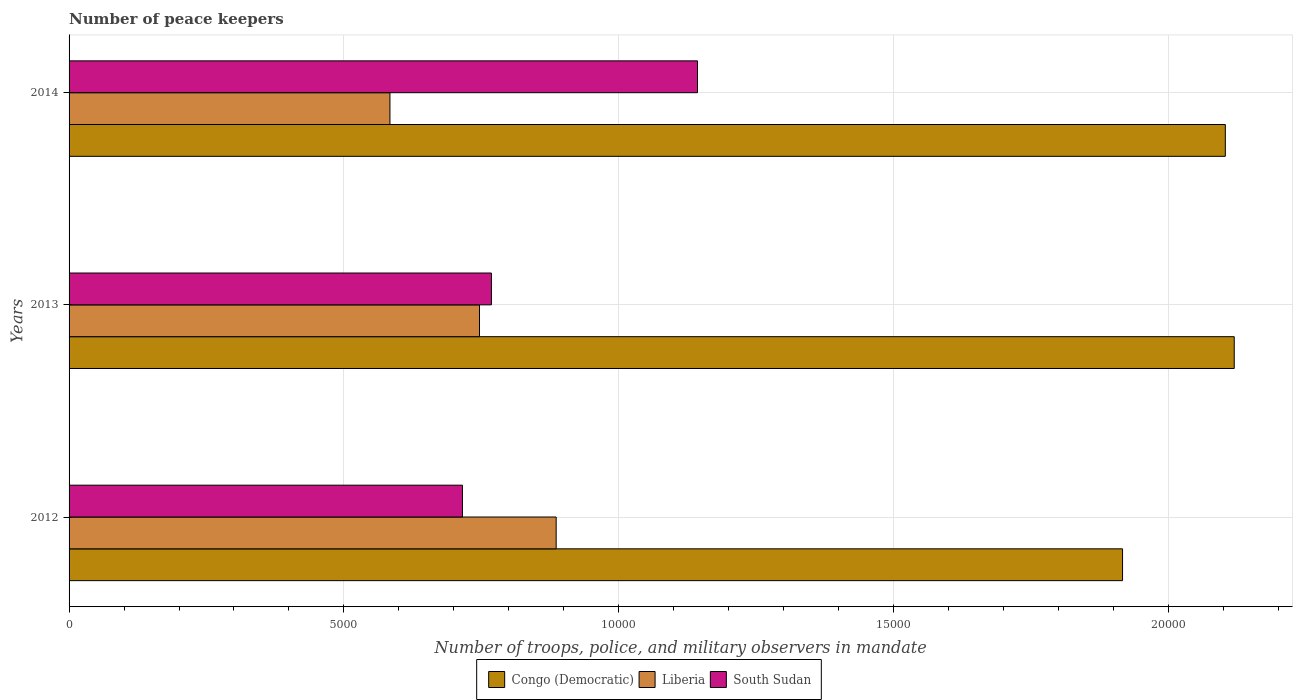How many different coloured bars are there?
Keep it short and to the point. 3. Are the number of bars on each tick of the Y-axis equal?
Offer a very short reply. Yes. How many bars are there on the 3rd tick from the bottom?
Give a very brief answer. 3. In how many cases, is the number of bars for a given year not equal to the number of legend labels?
Offer a terse response. 0. What is the number of peace keepers in in Liberia in 2013?
Give a very brief answer. 7467. Across all years, what is the maximum number of peace keepers in in South Sudan?
Make the answer very short. 1.14e+04. Across all years, what is the minimum number of peace keepers in in Liberia?
Offer a very short reply. 5838. In which year was the number of peace keepers in in Congo (Democratic) maximum?
Offer a very short reply. 2013. In which year was the number of peace keepers in in Liberia minimum?
Your answer should be very brief. 2014. What is the total number of peace keepers in in Liberia in the graph?
Keep it short and to the point. 2.22e+04. What is the difference between the number of peace keepers in in Congo (Democratic) in 2012 and that in 2014?
Your response must be concise. -1870. What is the difference between the number of peace keepers in in South Sudan in 2013 and the number of peace keepers in in Congo (Democratic) in 2012?
Give a very brief answer. -1.15e+04. What is the average number of peace keepers in in Liberia per year?
Your response must be concise. 7389. In the year 2012, what is the difference between the number of peace keepers in in Liberia and number of peace keepers in in South Sudan?
Offer a very short reply. 1705. In how many years, is the number of peace keepers in in Liberia greater than 2000 ?
Your answer should be very brief. 3. What is the ratio of the number of peace keepers in in Liberia in 2012 to that in 2013?
Offer a terse response. 1.19. Is the number of peace keepers in in Congo (Democratic) in 2013 less than that in 2014?
Offer a very short reply. No. What is the difference between the highest and the second highest number of peace keepers in in Liberia?
Give a very brief answer. 1395. What is the difference between the highest and the lowest number of peace keepers in in Liberia?
Your answer should be very brief. 3024. What does the 1st bar from the top in 2012 represents?
Provide a succinct answer. South Sudan. What does the 2nd bar from the bottom in 2012 represents?
Provide a succinct answer. Liberia. Is it the case that in every year, the sum of the number of peace keepers in in Liberia and number of peace keepers in in South Sudan is greater than the number of peace keepers in in Congo (Democratic)?
Make the answer very short. No. Are all the bars in the graph horizontal?
Provide a succinct answer. Yes. How many years are there in the graph?
Give a very brief answer. 3. What is the difference between two consecutive major ticks on the X-axis?
Give a very brief answer. 5000. Are the values on the major ticks of X-axis written in scientific E-notation?
Give a very brief answer. No. Does the graph contain grids?
Make the answer very short. Yes. How many legend labels are there?
Give a very brief answer. 3. What is the title of the graph?
Keep it short and to the point. Number of peace keepers. Does "World" appear as one of the legend labels in the graph?
Provide a short and direct response. No. What is the label or title of the X-axis?
Make the answer very short. Number of troops, police, and military observers in mandate. What is the label or title of the Y-axis?
Ensure brevity in your answer.  Years. What is the Number of troops, police, and military observers in mandate of Congo (Democratic) in 2012?
Offer a terse response. 1.92e+04. What is the Number of troops, police, and military observers in mandate in Liberia in 2012?
Give a very brief answer. 8862. What is the Number of troops, police, and military observers in mandate in South Sudan in 2012?
Keep it short and to the point. 7157. What is the Number of troops, police, and military observers in mandate in Congo (Democratic) in 2013?
Provide a succinct answer. 2.12e+04. What is the Number of troops, police, and military observers in mandate of Liberia in 2013?
Your answer should be very brief. 7467. What is the Number of troops, police, and military observers in mandate of South Sudan in 2013?
Offer a terse response. 7684. What is the Number of troops, police, and military observers in mandate of Congo (Democratic) in 2014?
Provide a succinct answer. 2.10e+04. What is the Number of troops, police, and military observers in mandate in Liberia in 2014?
Your answer should be compact. 5838. What is the Number of troops, police, and military observers in mandate of South Sudan in 2014?
Make the answer very short. 1.14e+04. Across all years, what is the maximum Number of troops, police, and military observers in mandate of Congo (Democratic)?
Provide a succinct answer. 2.12e+04. Across all years, what is the maximum Number of troops, police, and military observers in mandate of Liberia?
Ensure brevity in your answer.  8862. Across all years, what is the maximum Number of troops, police, and military observers in mandate of South Sudan?
Give a very brief answer. 1.14e+04. Across all years, what is the minimum Number of troops, police, and military observers in mandate in Congo (Democratic)?
Your answer should be compact. 1.92e+04. Across all years, what is the minimum Number of troops, police, and military observers in mandate in Liberia?
Your response must be concise. 5838. Across all years, what is the minimum Number of troops, police, and military observers in mandate in South Sudan?
Your response must be concise. 7157. What is the total Number of troops, police, and military observers in mandate of Congo (Democratic) in the graph?
Your answer should be compact. 6.14e+04. What is the total Number of troops, police, and military observers in mandate of Liberia in the graph?
Give a very brief answer. 2.22e+04. What is the total Number of troops, police, and military observers in mandate in South Sudan in the graph?
Keep it short and to the point. 2.63e+04. What is the difference between the Number of troops, police, and military observers in mandate of Congo (Democratic) in 2012 and that in 2013?
Make the answer very short. -2032. What is the difference between the Number of troops, police, and military observers in mandate of Liberia in 2012 and that in 2013?
Offer a very short reply. 1395. What is the difference between the Number of troops, police, and military observers in mandate in South Sudan in 2012 and that in 2013?
Offer a terse response. -527. What is the difference between the Number of troops, police, and military observers in mandate in Congo (Democratic) in 2012 and that in 2014?
Keep it short and to the point. -1870. What is the difference between the Number of troops, police, and military observers in mandate of Liberia in 2012 and that in 2014?
Make the answer very short. 3024. What is the difference between the Number of troops, police, and military observers in mandate of South Sudan in 2012 and that in 2014?
Give a very brief answer. -4276. What is the difference between the Number of troops, police, and military observers in mandate in Congo (Democratic) in 2013 and that in 2014?
Keep it short and to the point. 162. What is the difference between the Number of troops, police, and military observers in mandate in Liberia in 2013 and that in 2014?
Keep it short and to the point. 1629. What is the difference between the Number of troops, police, and military observers in mandate of South Sudan in 2013 and that in 2014?
Your answer should be compact. -3749. What is the difference between the Number of troops, police, and military observers in mandate in Congo (Democratic) in 2012 and the Number of troops, police, and military observers in mandate in Liberia in 2013?
Offer a terse response. 1.17e+04. What is the difference between the Number of troops, police, and military observers in mandate of Congo (Democratic) in 2012 and the Number of troops, police, and military observers in mandate of South Sudan in 2013?
Make the answer very short. 1.15e+04. What is the difference between the Number of troops, police, and military observers in mandate of Liberia in 2012 and the Number of troops, police, and military observers in mandate of South Sudan in 2013?
Provide a succinct answer. 1178. What is the difference between the Number of troops, police, and military observers in mandate of Congo (Democratic) in 2012 and the Number of troops, police, and military observers in mandate of Liberia in 2014?
Offer a very short reply. 1.33e+04. What is the difference between the Number of troops, police, and military observers in mandate in Congo (Democratic) in 2012 and the Number of troops, police, and military observers in mandate in South Sudan in 2014?
Give a very brief answer. 7733. What is the difference between the Number of troops, police, and military observers in mandate of Liberia in 2012 and the Number of troops, police, and military observers in mandate of South Sudan in 2014?
Ensure brevity in your answer.  -2571. What is the difference between the Number of troops, police, and military observers in mandate of Congo (Democratic) in 2013 and the Number of troops, police, and military observers in mandate of Liberia in 2014?
Provide a short and direct response. 1.54e+04. What is the difference between the Number of troops, police, and military observers in mandate of Congo (Democratic) in 2013 and the Number of troops, police, and military observers in mandate of South Sudan in 2014?
Give a very brief answer. 9765. What is the difference between the Number of troops, police, and military observers in mandate of Liberia in 2013 and the Number of troops, police, and military observers in mandate of South Sudan in 2014?
Give a very brief answer. -3966. What is the average Number of troops, police, and military observers in mandate in Congo (Democratic) per year?
Ensure brevity in your answer.  2.05e+04. What is the average Number of troops, police, and military observers in mandate of Liberia per year?
Offer a terse response. 7389. What is the average Number of troops, police, and military observers in mandate of South Sudan per year?
Make the answer very short. 8758. In the year 2012, what is the difference between the Number of troops, police, and military observers in mandate of Congo (Democratic) and Number of troops, police, and military observers in mandate of Liberia?
Your response must be concise. 1.03e+04. In the year 2012, what is the difference between the Number of troops, police, and military observers in mandate in Congo (Democratic) and Number of troops, police, and military observers in mandate in South Sudan?
Give a very brief answer. 1.20e+04. In the year 2012, what is the difference between the Number of troops, police, and military observers in mandate in Liberia and Number of troops, police, and military observers in mandate in South Sudan?
Your answer should be compact. 1705. In the year 2013, what is the difference between the Number of troops, police, and military observers in mandate of Congo (Democratic) and Number of troops, police, and military observers in mandate of Liberia?
Keep it short and to the point. 1.37e+04. In the year 2013, what is the difference between the Number of troops, police, and military observers in mandate of Congo (Democratic) and Number of troops, police, and military observers in mandate of South Sudan?
Provide a short and direct response. 1.35e+04. In the year 2013, what is the difference between the Number of troops, police, and military observers in mandate of Liberia and Number of troops, police, and military observers in mandate of South Sudan?
Your response must be concise. -217. In the year 2014, what is the difference between the Number of troops, police, and military observers in mandate in Congo (Democratic) and Number of troops, police, and military observers in mandate in Liberia?
Provide a short and direct response. 1.52e+04. In the year 2014, what is the difference between the Number of troops, police, and military observers in mandate in Congo (Democratic) and Number of troops, police, and military observers in mandate in South Sudan?
Provide a short and direct response. 9603. In the year 2014, what is the difference between the Number of troops, police, and military observers in mandate of Liberia and Number of troops, police, and military observers in mandate of South Sudan?
Keep it short and to the point. -5595. What is the ratio of the Number of troops, police, and military observers in mandate of Congo (Democratic) in 2012 to that in 2013?
Ensure brevity in your answer.  0.9. What is the ratio of the Number of troops, police, and military observers in mandate in Liberia in 2012 to that in 2013?
Provide a short and direct response. 1.19. What is the ratio of the Number of troops, police, and military observers in mandate in South Sudan in 2012 to that in 2013?
Offer a very short reply. 0.93. What is the ratio of the Number of troops, police, and military observers in mandate of Congo (Democratic) in 2012 to that in 2014?
Provide a short and direct response. 0.91. What is the ratio of the Number of troops, police, and military observers in mandate in Liberia in 2012 to that in 2014?
Ensure brevity in your answer.  1.52. What is the ratio of the Number of troops, police, and military observers in mandate in South Sudan in 2012 to that in 2014?
Ensure brevity in your answer.  0.63. What is the ratio of the Number of troops, police, and military observers in mandate in Congo (Democratic) in 2013 to that in 2014?
Give a very brief answer. 1.01. What is the ratio of the Number of troops, police, and military observers in mandate of Liberia in 2013 to that in 2014?
Keep it short and to the point. 1.28. What is the ratio of the Number of troops, police, and military observers in mandate in South Sudan in 2013 to that in 2014?
Keep it short and to the point. 0.67. What is the difference between the highest and the second highest Number of troops, police, and military observers in mandate in Congo (Democratic)?
Offer a very short reply. 162. What is the difference between the highest and the second highest Number of troops, police, and military observers in mandate in Liberia?
Your answer should be compact. 1395. What is the difference between the highest and the second highest Number of troops, police, and military observers in mandate in South Sudan?
Provide a succinct answer. 3749. What is the difference between the highest and the lowest Number of troops, police, and military observers in mandate of Congo (Democratic)?
Make the answer very short. 2032. What is the difference between the highest and the lowest Number of troops, police, and military observers in mandate in Liberia?
Offer a terse response. 3024. What is the difference between the highest and the lowest Number of troops, police, and military observers in mandate of South Sudan?
Ensure brevity in your answer.  4276. 